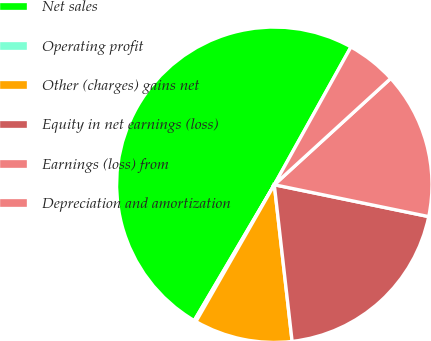Convert chart to OTSL. <chart><loc_0><loc_0><loc_500><loc_500><pie_chart><fcel>Net sales<fcel>Operating profit<fcel>Other (charges) gains net<fcel>Equity in net earnings (loss)<fcel>Earnings (loss) from<fcel>Depreciation and amortization<nl><fcel>49.61%<fcel>0.2%<fcel>10.08%<fcel>19.96%<fcel>15.02%<fcel>5.14%<nl></chart> 